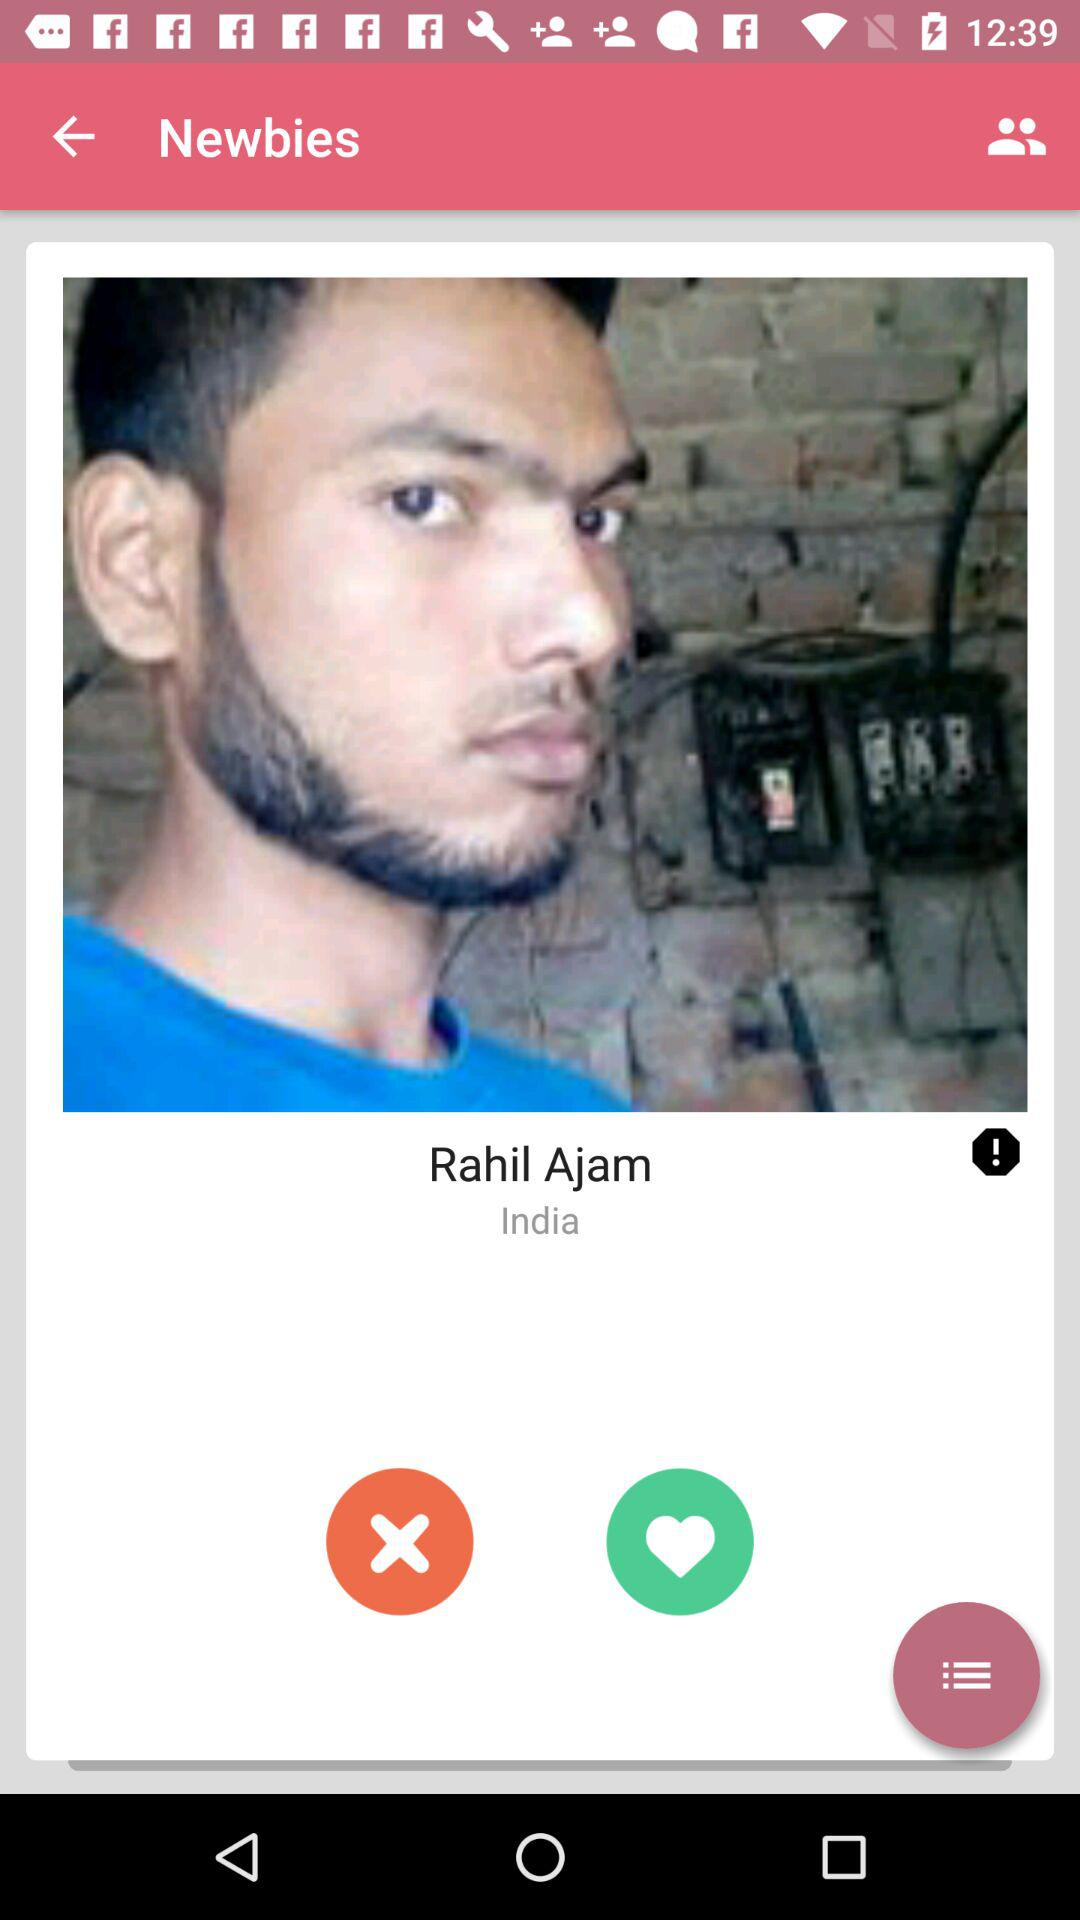What is the location? The location is India. 